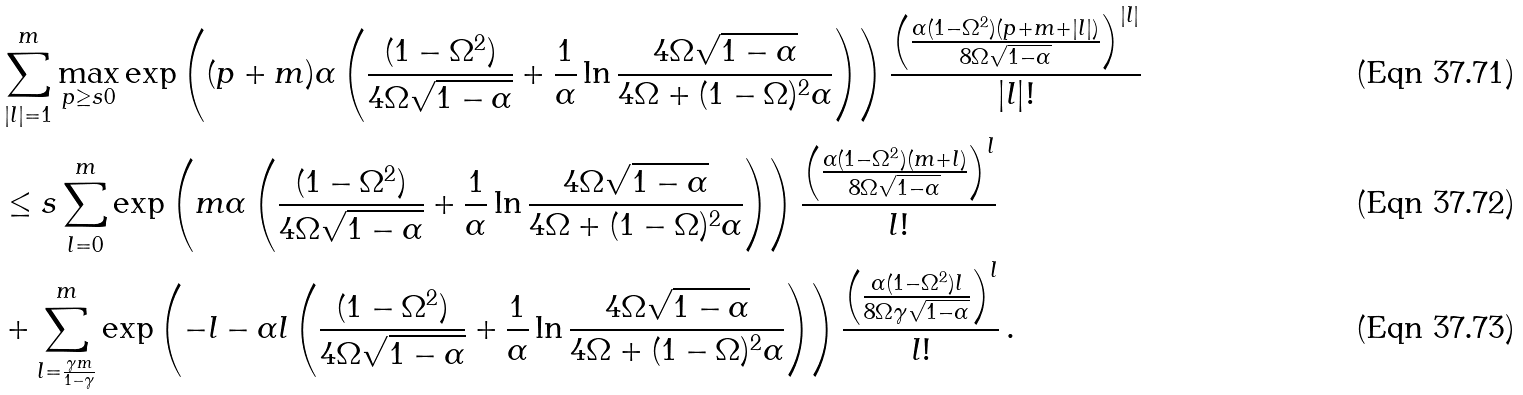<formula> <loc_0><loc_0><loc_500><loc_500>& \sum _ { | l | = 1 } ^ { m } \max _ { p \geq s 0 } \exp \left ( ( p + m ) \alpha \left ( \frac { ( 1 - \Omega ^ { 2 } ) } { 4 \Omega \sqrt { 1 - \alpha } } + \frac { 1 } { \alpha } \ln \frac { 4 \Omega \sqrt { 1 - \alpha } } { 4 \Omega + ( 1 - \Omega ) ^ { 2 } \alpha } \right ) \right ) \frac { \left ( \frac { \alpha ( 1 - \Omega ^ { 2 } ) ( p + m + | l | ) } { 8 \Omega \sqrt { 1 - \alpha } } \right ) ^ { | l | } } { | l | ! } \\ & \leq s \sum _ { l = 0 } ^ { m } \exp \left ( m \alpha \left ( \frac { ( 1 - \Omega ^ { 2 } ) } { 4 \Omega \sqrt { 1 - \alpha } } + \frac { 1 } { \alpha } \ln \frac { 4 \Omega \sqrt { 1 - \alpha } } { 4 \Omega + ( 1 - \Omega ) ^ { 2 } \alpha } \right ) \right ) \frac { \left ( \frac { \alpha ( 1 - \Omega ^ { 2 } ) ( m + l ) } { 8 \Omega \sqrt { 1 - \alpha } } \right ) ^ { l } } { l ! } \\ & + \sum _ { l = \frac { \gamma m } { 1 - \gamma } } ^ { m } \exp \left ( - l - \alpha l \left ( \frac { ( 1 - \Omega ^ { 2 } ) } { 4 \Omega \sqrt { 1 - \alpha } } + \frac { 1 } { \alpha } \ln \frac { 4 \Omega \sqrt { 1 - \alpha } } { 4 \Omega + ( 1 - \Omega ) ^ { 2 } \alpha } \right ) \right ) \frac { \left ( \frac { \alpha ( 1 - \Omega ^ { 2 } ) l } { 8 \Omega \gamma \sqrt { 1 - \alpha } } \right ) ^ { l } } { l ! } \, .</formula> 